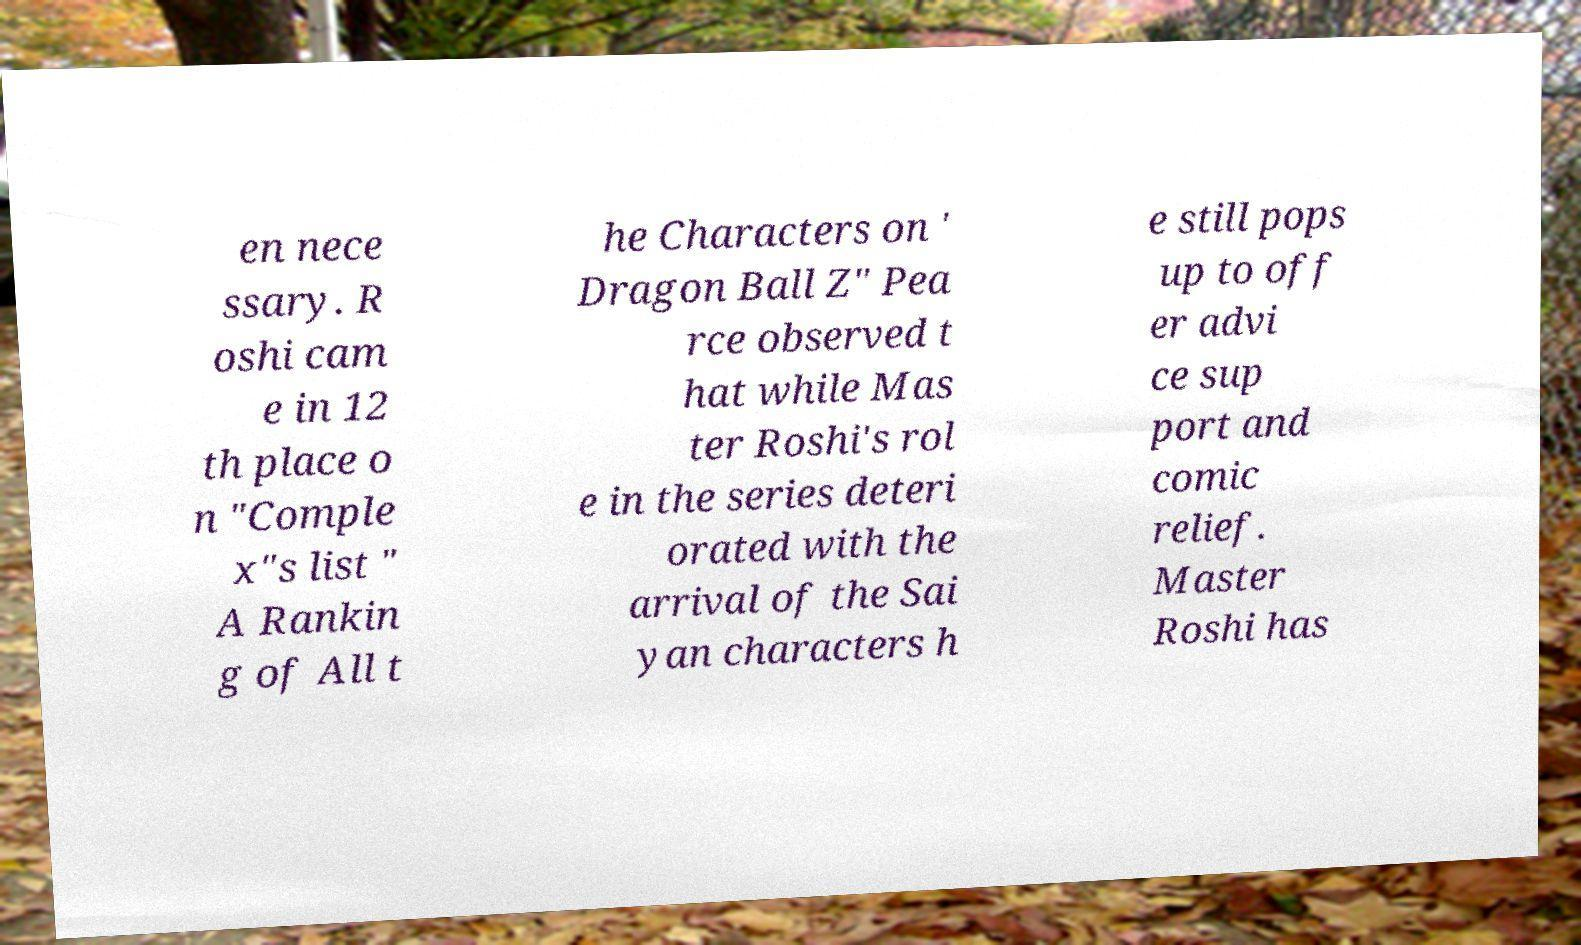Could you extract and type out the text from this image? en nece ssary. R oshi cam e in 12 th place o n "Comple x"s list " A Rankin g of All t he Characters on ' Dragon Ball Z" Pea rce observed t hat while Mas ter Roshi's rol e in the series deteri orated with the arrival of the Sai yan characters h e still pops up to off er advi ce sup port and comic relief. Master Roshi has 